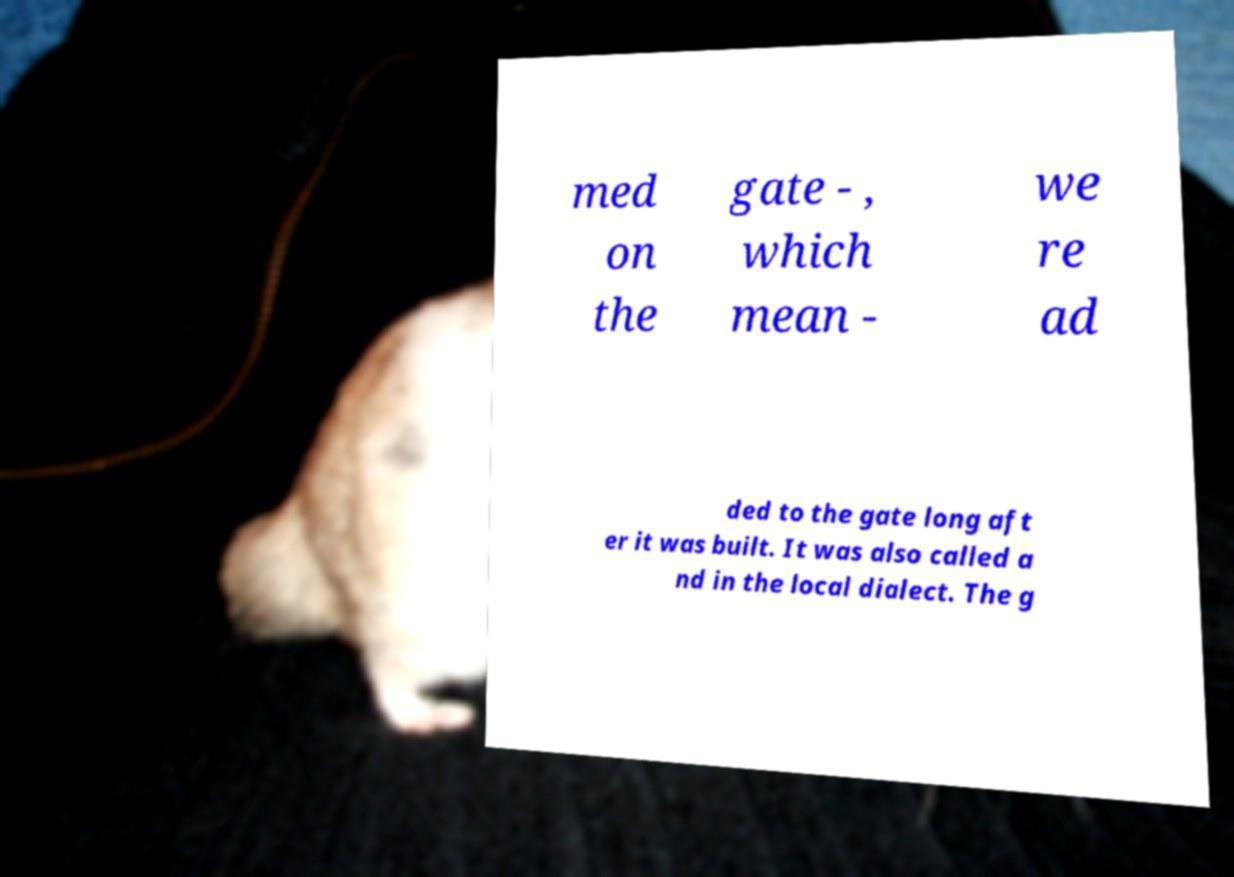Please identify and transcribe the text found in this image. med on the gate - , which mean - we re ad ded to the gate long aft er it was built. It was also called a nd in the local dialect. The g 